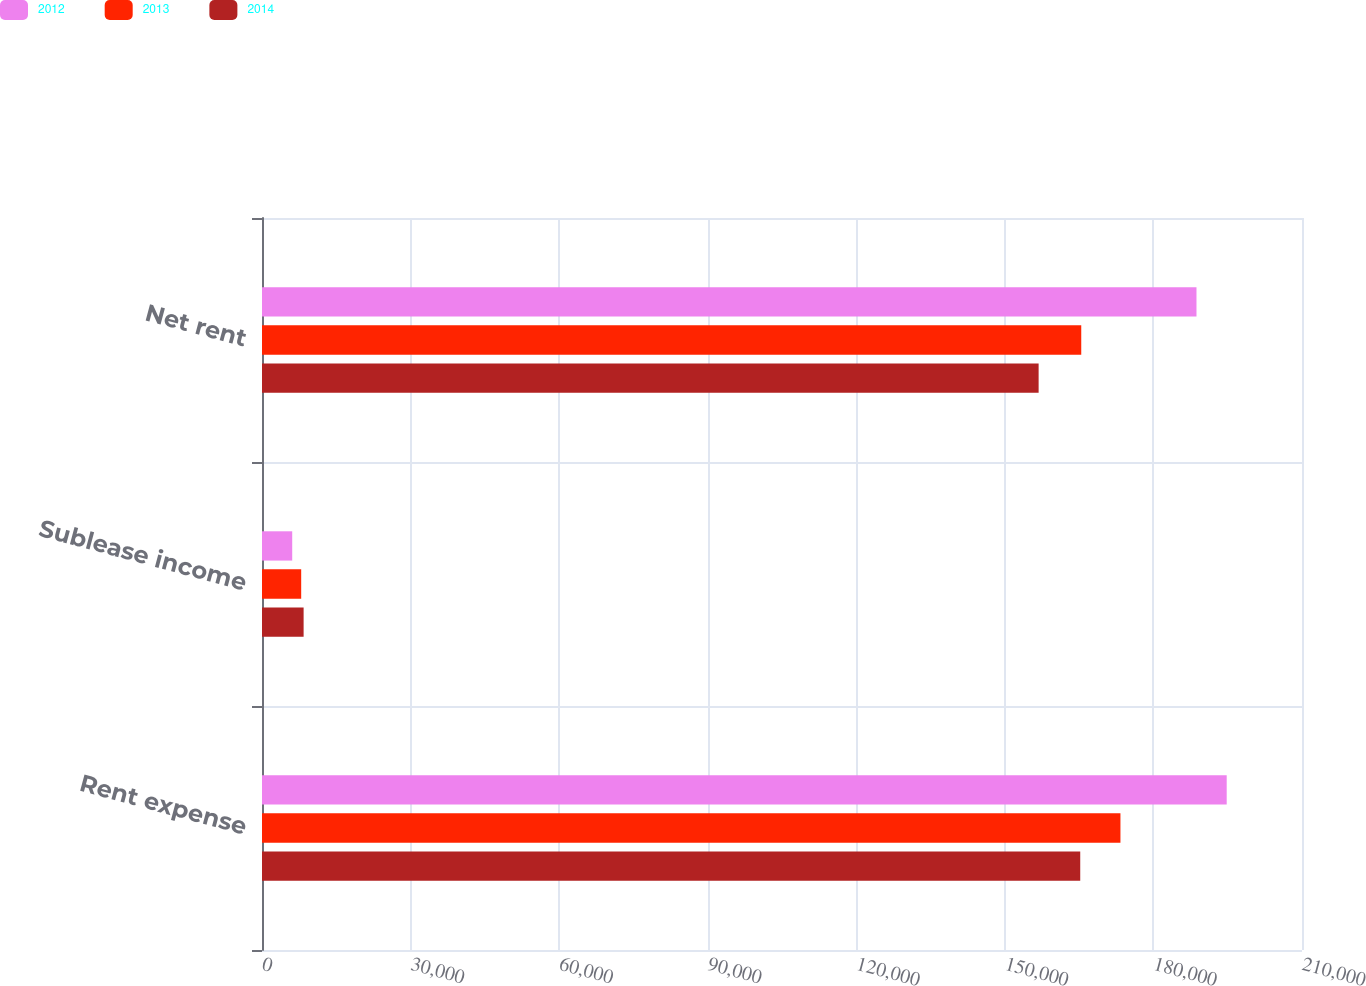Convert chart to OTSL. <chart><loc_0><loc_0><loc_500><loc_500><stacked_bar_chart><ecel><fcel>Rent expense<fcel>Sublease income<fcel>Net rent<nl><fcel>2012<fcel>194796<fcel>6102<fcel>188694<nl><fcel>2013<fcel>173340<fcel>7914<fcel>165426<nl><fcel>2014<fcel>165221<fcel>8402<fcel>156819<nl></chart> 